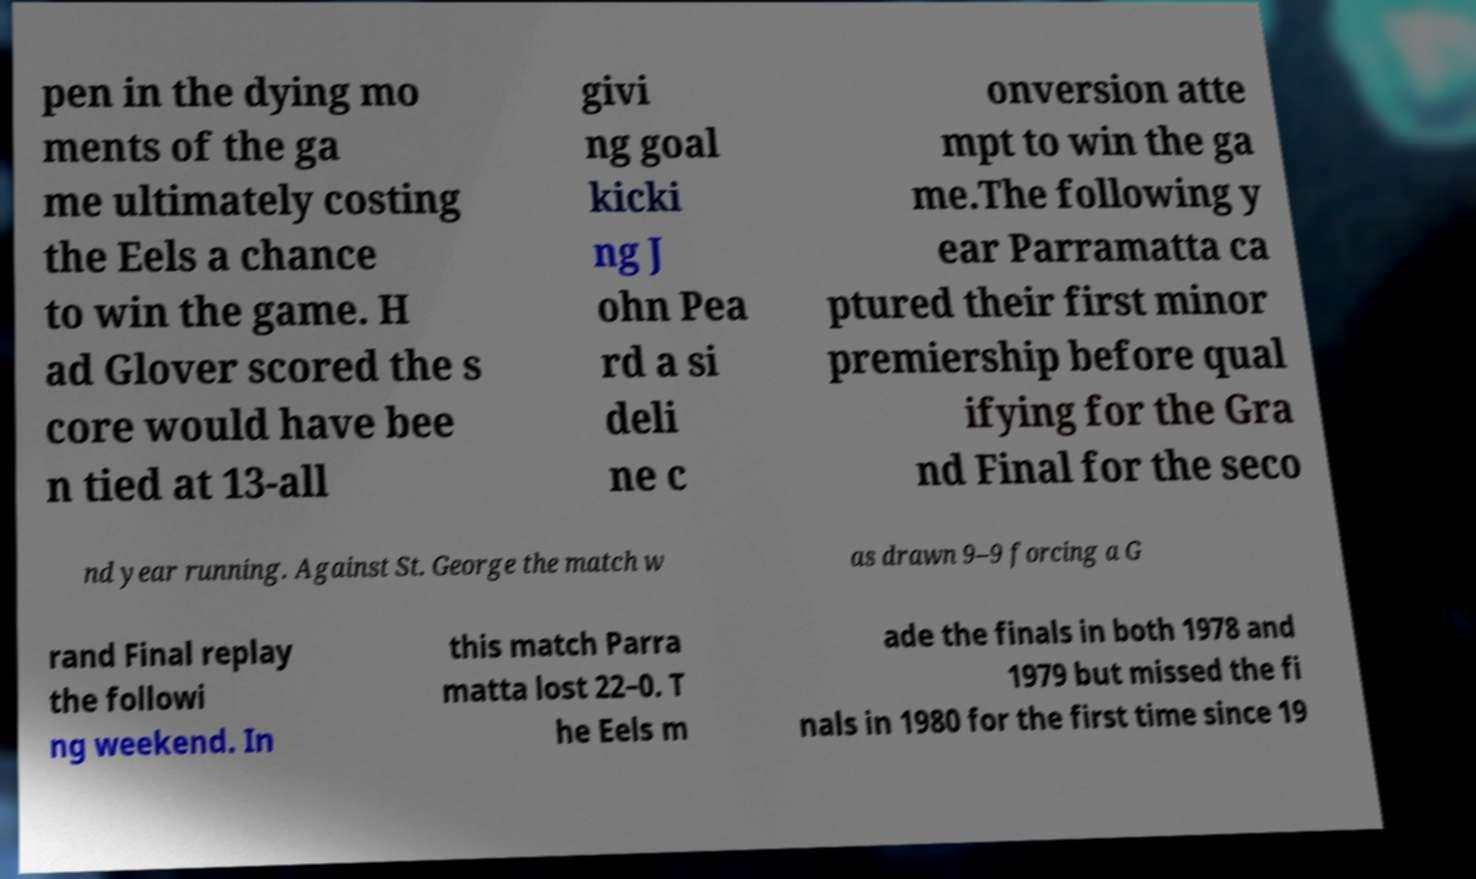I need the written content from this picture converted into text. Can you do that? pen in the dying mo ments of the ga me ultimately costing the Eels a chance to win the game. H ad Glover scored the s core would have bee n tied at 13-all givi ng goal kicki ng J ohn Pea rd a si deli ne c onversion atte mpt to win the ga me.The following y ear Parramatta ca ptured their first minor premiership before qual ifying for the Gra nd Final for the seco nd year running. Against St. George the match w as drawn 9–9 forcing a G rand Final replay the followi ng weekend. In this match Parra matta lost 22–0. T he Eels m ade the finals in both 1978 and 1979 but missed the fi nals in 1980 for the first time since 19 